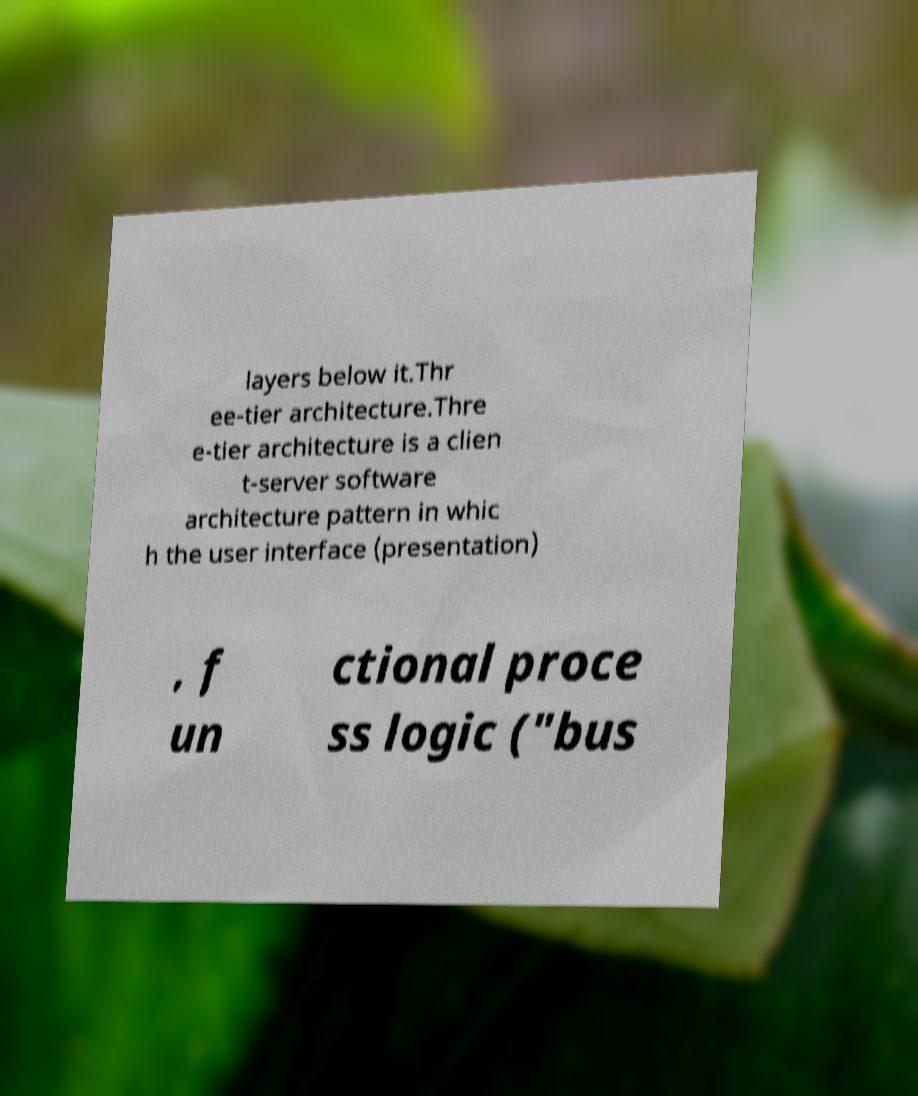What messages or text are displayed in this image? I need them in a readable, typed format. layers below it.Thr ee-tier architecture.Thre e-tier architecture is a clien t-server software architecture pattern in whic h the user interface (presentation) , f un ctional proce ss logic ("bus 